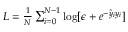Convert formula to latex. <formula><loc_0><loc_0><loc_500><loc_500>\begin{array} { r } { L = \frac { 1 } { N } \sum _ { i = 0 } ^ { N - 1 } \log [ \epsilon + e ^ { - \hat { y } _ { i } y _ { i } } ] } \end{array}</formula> 